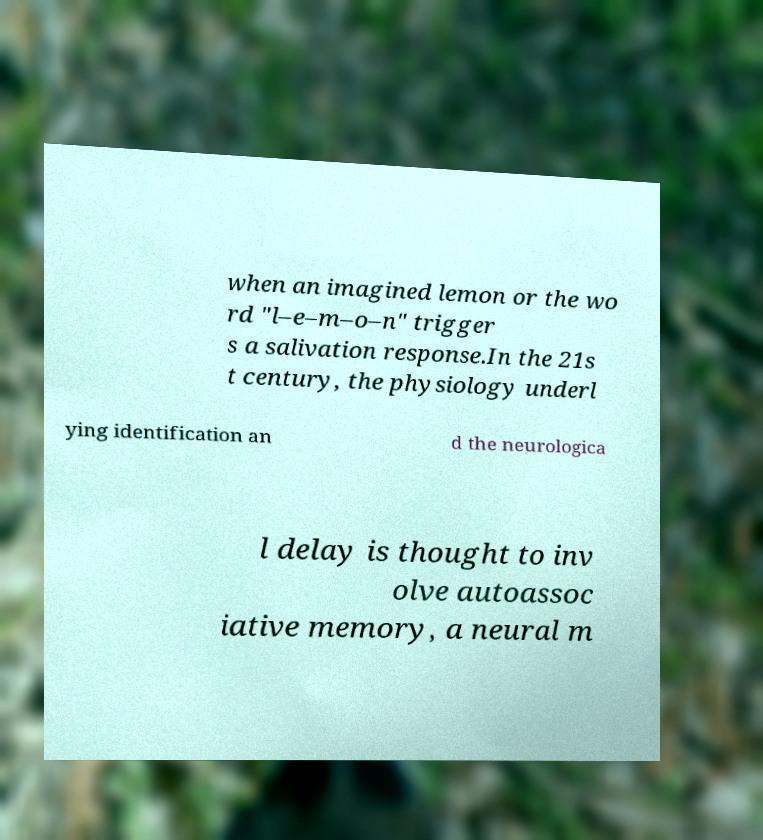What messages or text are displayed in this image? I need them in a readable, typed format. when an imagined lemon or the wo rd "l–e–m–o–n" trigger s a salivation response.In the 21s t century, the physiology underl ying identification an d the neurologica l delay is thought to inv olve autoassoc iative memory, a neural m 